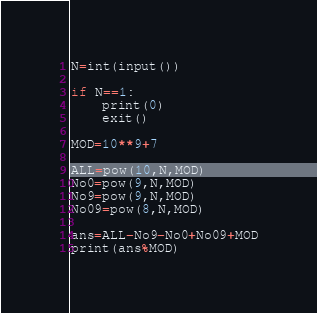<code> <loc_0><loc_0><loc_500><loc_500><_Python_>N=int(input())

if N==1:
    print(0)
    exit()

MOD=10**9+7

ALL=pow(10,N,MOD)
No0=pow(9,N,MOD)
No9=pow(9,N,MOD)
No09=pow(8,N,MOD)

ans=ALL-No9-No0+No09+MOD
print(ans%MOD)
</code> 